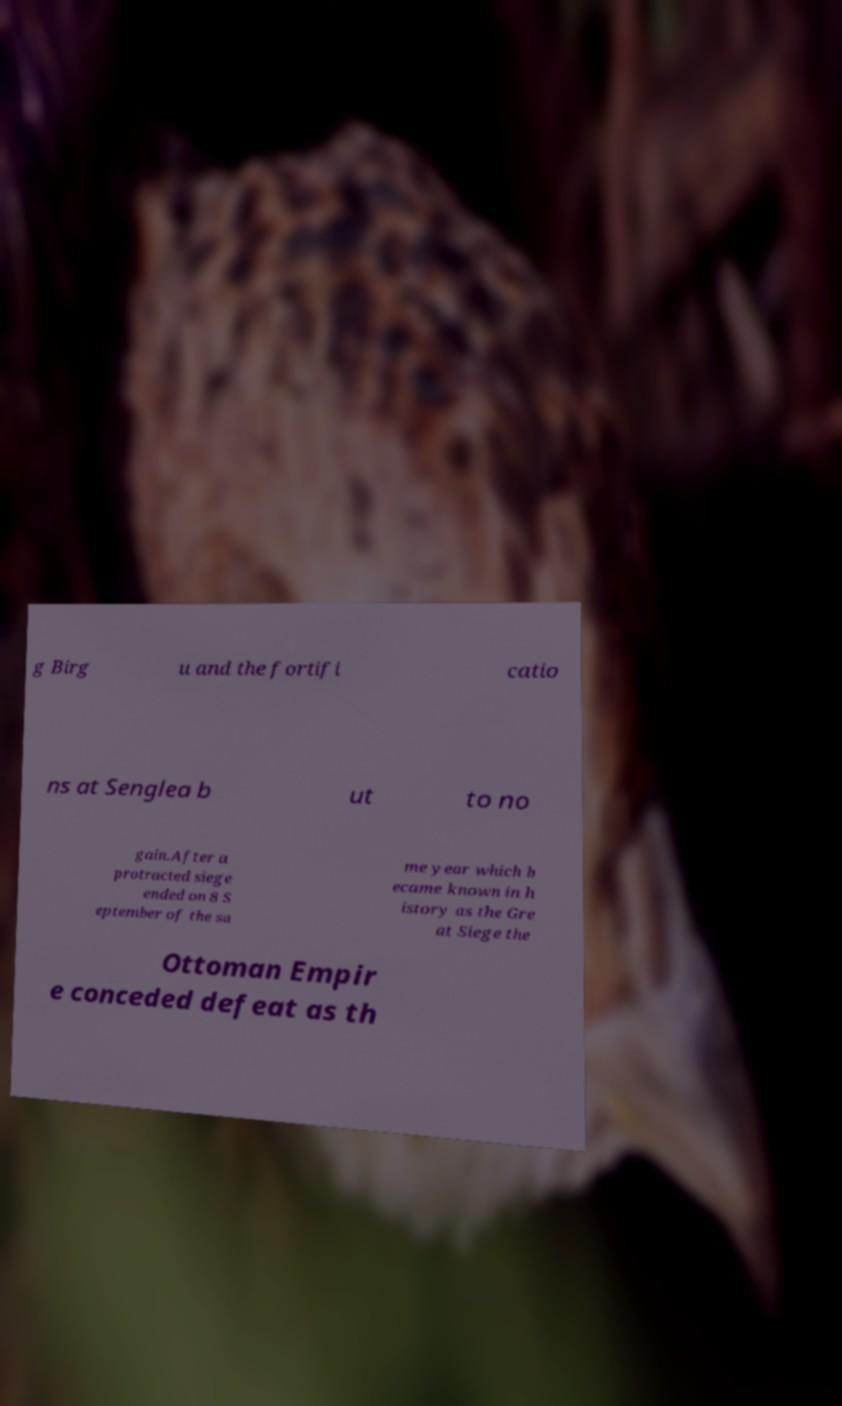Please read and relay the text visible in this image. What does it say? g Birg u and the fortifi catio ns at Senglea b ut to no gain.After a protracted siege ended on 8 S eptember of the sa me year which b ecame known in h istory as the Gre at Siege the Ottoman Empir e conceded defeat as th 